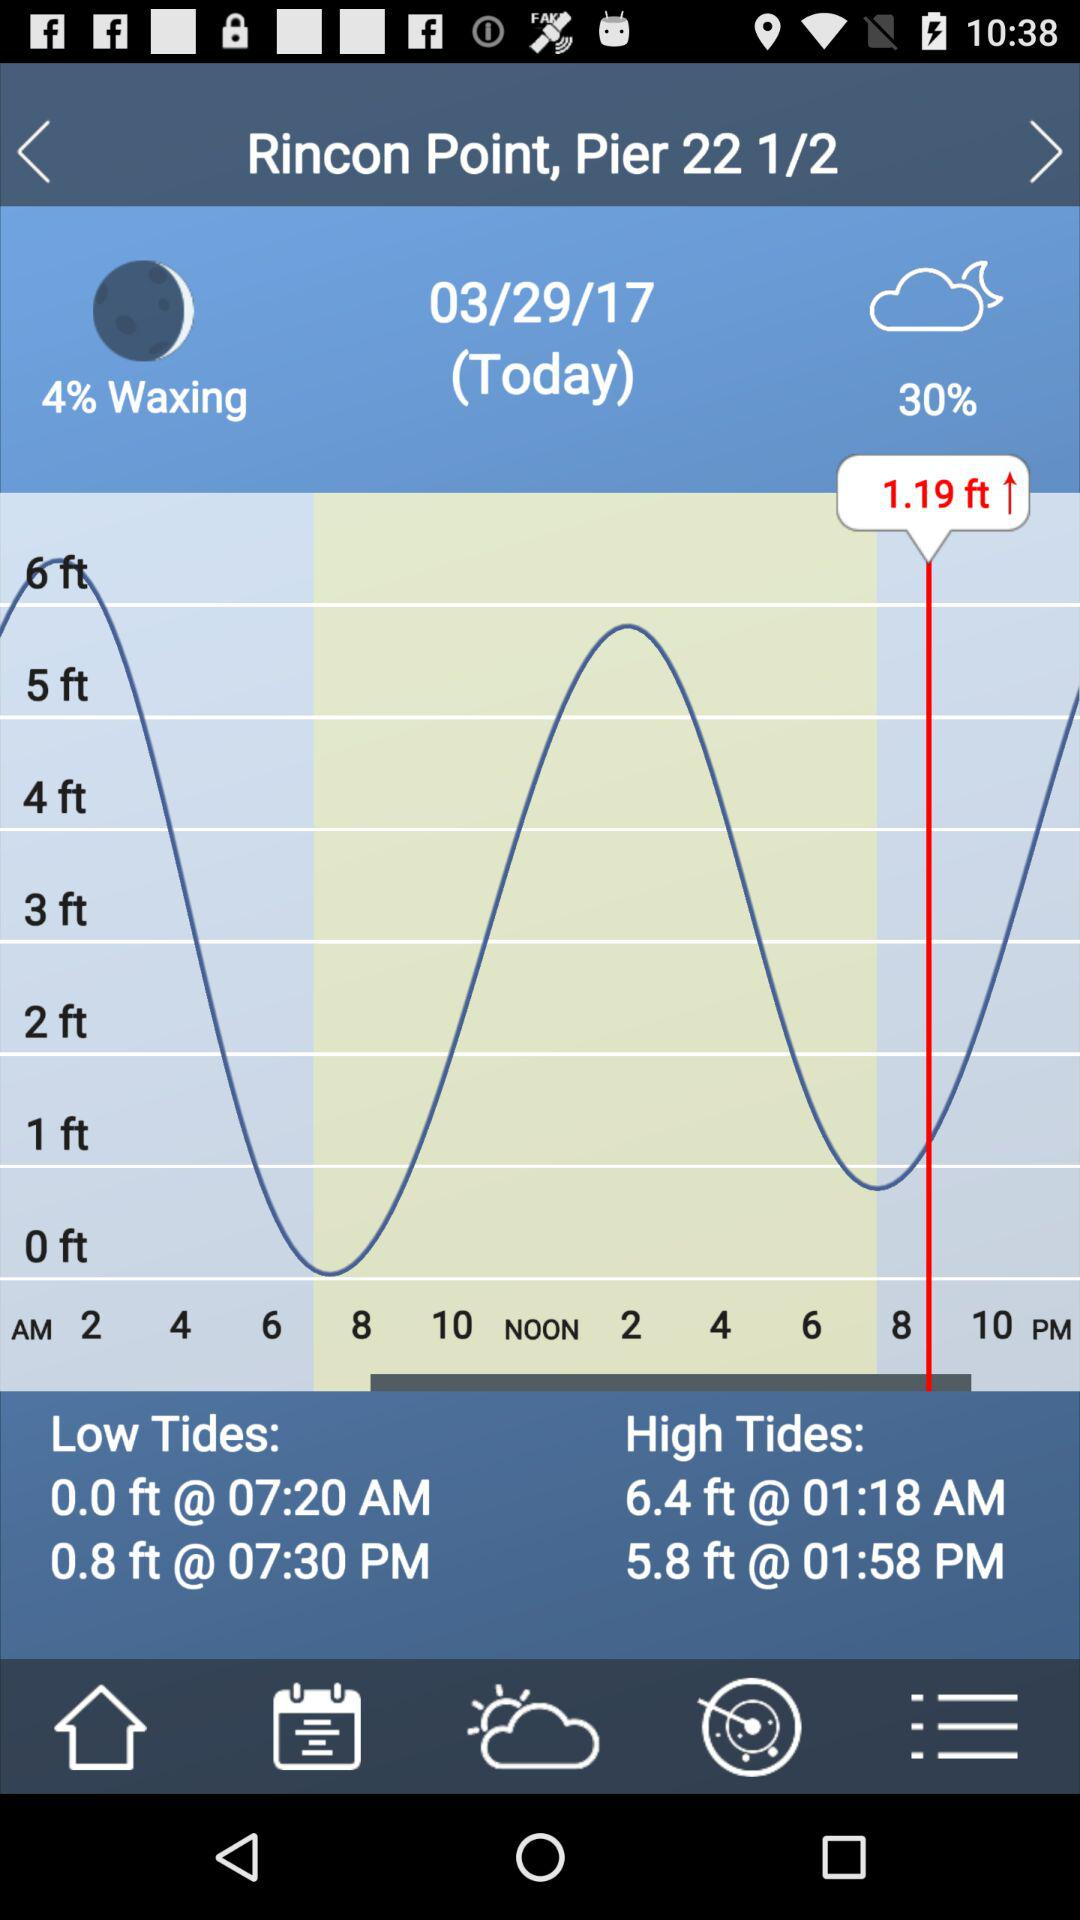What is the time of low tides? The time of low tides are 07:20 AM and 07:30 PM. 